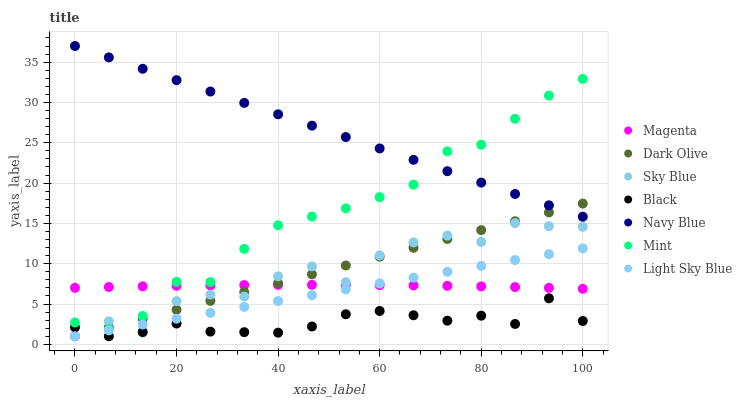Does Black have the minimum area under the curve?
Answer yes or no. Yes. Does Navy Blue have the maximum area under the curve?
Answer yes or no. Yes. Does Dark Olive have the minimum area under the curve?
Answer yes or no. No. Does Dark Olive have the maximum area under the curve?
Answer yes or no. No. Is Light Sky Blue the smoothest?
Answer yes or no. Yes. Is Sky Blue the roughest?
Answer yes or no. Yes. Is Dark Olive the smoothest?
Answer yes or no. No. Is Dark Olive the roughest?
Answer yes or no. No. Does Dark Olive have the lowest value?
Answer yes or no. Yes. Does Magenta have the lowest value?
Answer yes or no. No. Does Navy Blue have the highest value?
Answer yes or no. Yes. Does Dark Olive have the highest value?
Answer yes or no. No. Is Black less than Mint?
Answer yes or no. Yes. Is Mint greater than Light Sky Blue?
Answer yes or no. Yes. Does Magenta intersect Dark Olive?
Answer yes or no. Yes. Is Magenta less than Dark Olive?
Answer yes or no. No. Is Magenta greater than Dark Olive?
Answer yes or no. No. Does Black intersect Mint?
Answer yes or no. No. 